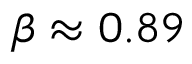Convert formula to latex. <formula><loc_0><loc_0><loc_500><loc_500>\beta \approx 0 . 8 9</formula> 